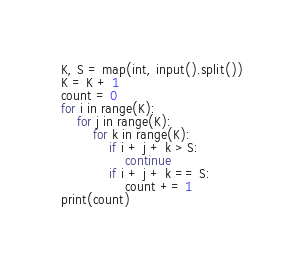<code> <loc_0><loc_0><loc_500><loc_500><_Python_>K, S = map(int, input().split())
K = K + 1
count = 0
for i in range(K):
    for j in range(K):
        for k in range(K):
            if i + j + k > S:
                continue
            if i + j + k == S:
                count += 1
print(count)
</code> 